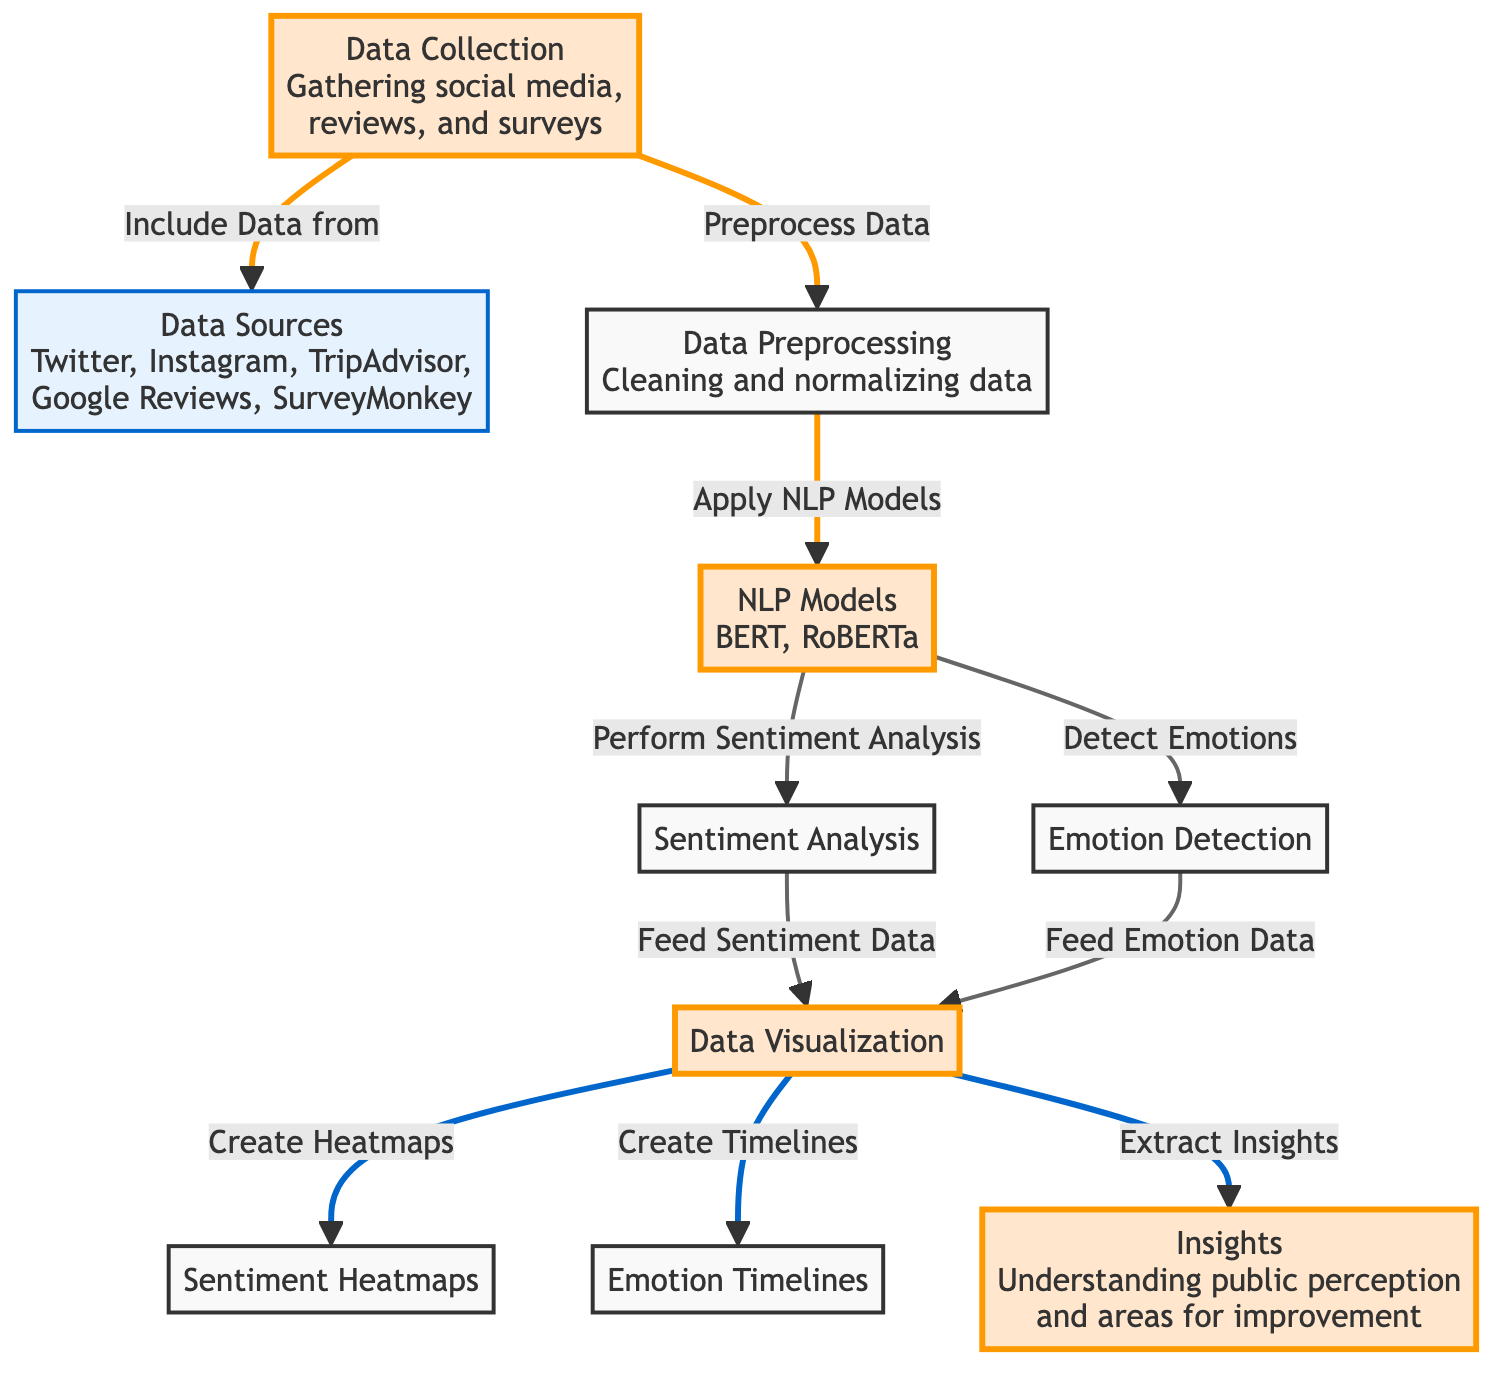What is the first step in the diagram? The first step in the diagram is "Data Collection," where social media, reviews, and surveys are gathered. This is indicated in the flowchart as the starting point before any processing happens.
Answer: Data Collection Which NLP models are used in this analysis? The diagram specifies the use of two NLP models: BERT and RoBERTa. This information is clearly shown in the "NLP Models" node.
Answer: BERT, RoBERTa How many data sources are mentioned in the diagram? There are five data sources listed in the diagram: Twitter, Instagram, TripAdvisor, Google Reviews, and SurveyMonkey. Counting these distinct sources gives a total of five.
Answer: 5 What type of data visualization is produced from sentiment analysis? The diagram states that "Sentiment Heatmaps" are produced as a form of data visualization from sentiment analysis. This node indicates a specific output of the overall analysis.
Answer: Sentiment Heatmaps What follows after the emotion detection process in the flowchart? After emotion detection, the next step is data visualization. This sequence demonstrates how outputs from emotion detection feed into the overall visualization process.
Answer: Data Visualization Which node provides insights into public perception? The node labeled "Insights" provides understanding of public perception and areas for improvement, as explicitly noted within its description in the diagram.
Answer: Insights What are the two outcomes of the data visualization step? The data visualization step leads to two distinct outcomes: "Sentiment Heatmaps" and "Emotion Timelines," clearly indicated in the respective nodes that follow data visualization.
Answer: Sentiment Heatmaps, Emotion Timelines Which model applies to both sentiment analysis and emotion detection? The "NLP Models" node applies to both sentiment analysis and emotion detection as it is placed before these two processes, signifying that they both utilize the NLP models mentioned.
Answer: NLP Models What is the primary purpose of the entire process depicted in the diagram? The overall purpose of the process is to perform "Automated Customer Sentiment Analysis," which aims at analyzing feedback regarding UAE cultural festivals. This is derived from the title's focus on sentiment analysis.
Answer: Automated Customer Sentiment Analysis 